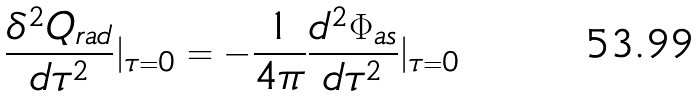<formula> <loc_0><loc_0><loc_500><loc_500>\frac { \delta ^ { 2 } Q _ { r a d } } { d \tau ^ { 2 } } | _ { \tau = 0 } = - \frac { 1 } { 4 \pi } \frac { d ^ { 2 } \Phi _ { a s } } { d \tau ^ { 2 } } | _ { \tau = 0 }</formula> 